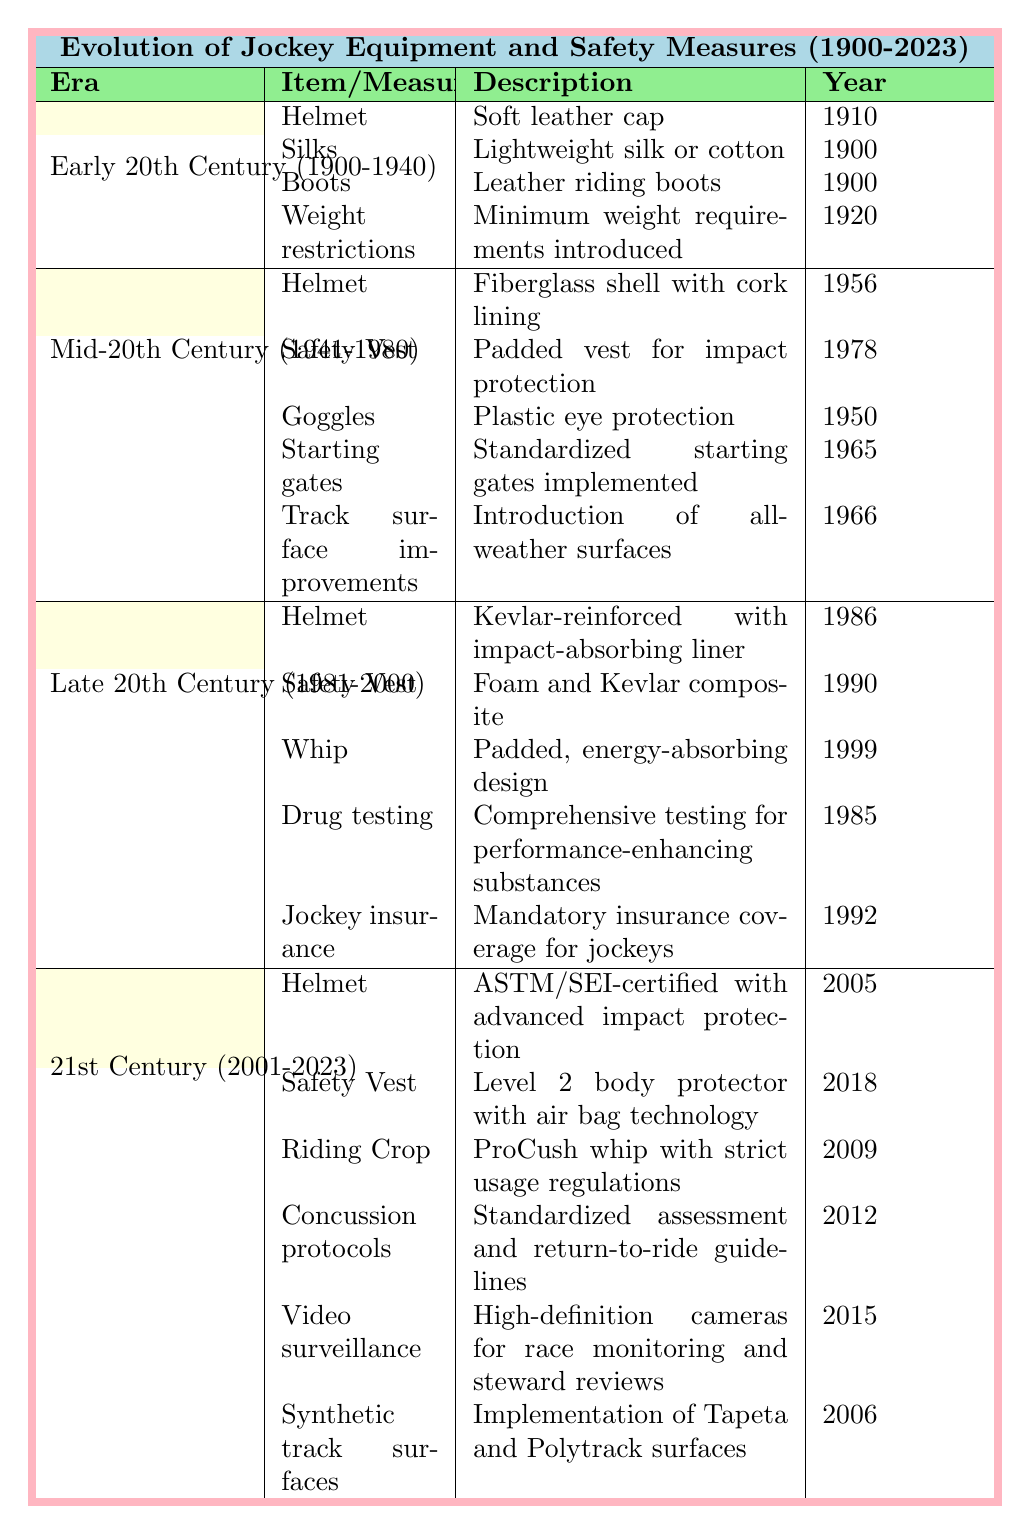What item was introduced in 1900? Referring to the table, we can see that both "Silks" and "Boots" were introduced in 1900 in the Early 20th Century era.
Answer: Silks and Boots In which year was the safety vest first introduced? Checking the table, we see that the "Safety Vest" was introduced in 1978 in the Mid-20th Century era.
Answer: 1978 What type of helmet was first introduced in 2005? The table specifies that the helmet introduced in 2005 is described as "ASTM/SEI-certified with advanced impact protection."
Answer: ASTM/SEI-certified helmet How many total safety measures were implemented in the Late 20th Century? In the Late 20th Century, two safety measures are listed: "Drug testing" and "Jockey insurance." Therefore, the total count of safety measures is 2.
Answer: 2 Did the introduction of standardized starting gates occur before or after the introduction of the fiberglass helmet? The fiberglass helmet was introduced in 1956, and the standardized starting gates were implemented in 1965, indicating the starting gates came after the helmet.
Answer: After Which era saw the introduction of the padded, energy-absorbing design for the whip? According to the table, the padded, energy-absorbing whip was introduced in the Late 20th Century in 1999.
Answer: Late 20th Century What are the two specific safety measures implemented in the 21st Century? The table lists three safety measures implemented in the 21st Century: "Concussion protocols," "Video surveillance," and "Synthetic track surfaces." Thus, two of them would be "Concussion protocols" and "Video surveillance."
Answer: Concussion protocols and Video surveillance Which era had the most pieces of equipment listed? By counting the pieces of equipment, the Early 20th Century has 3 items, the Mid-20th Century has 3 items, the Late 20th Century has 3 items, and the 21st Century has 3 items, making them all equal.
Answer: They are all equal Can you find a carryover of equipment types from one era to the next? Yes, the helmet appears in all eras with different designs and specifications, demonstrating a continuity in that type of equipment.
Answer: Yes, the helmet What year did the introduction of the air bag technology for safety vests occur? The table shows that air bag technology was introduced for safety vests in 2018 as part of the equipment in the 21st Century.
Answer: 2018 